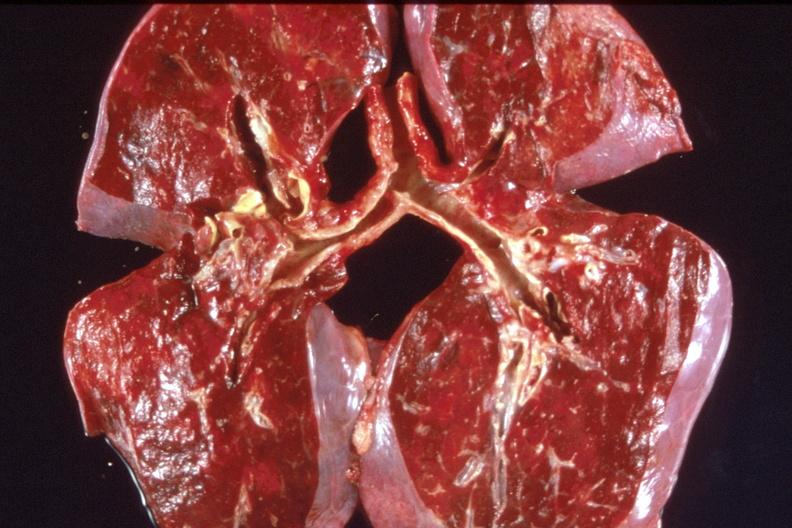where is this?
Answer the question using a single word or phrase. Lung 